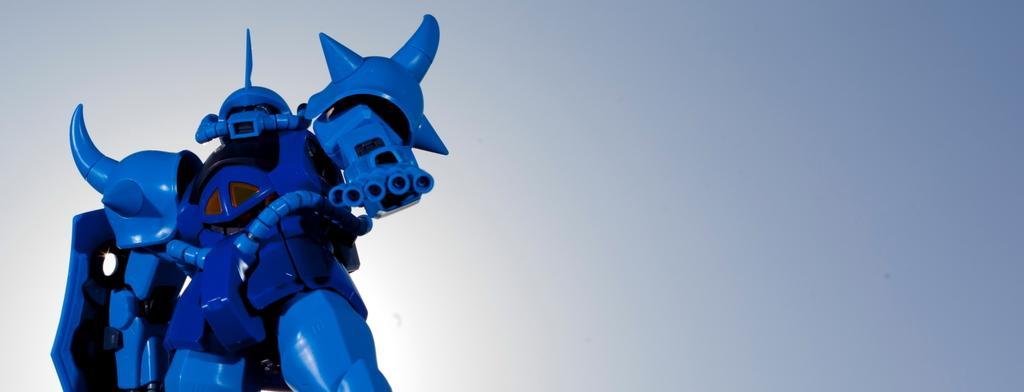Can you describe this image briefly? In this picture, there is a robot towards the left. It is in blue in color. 